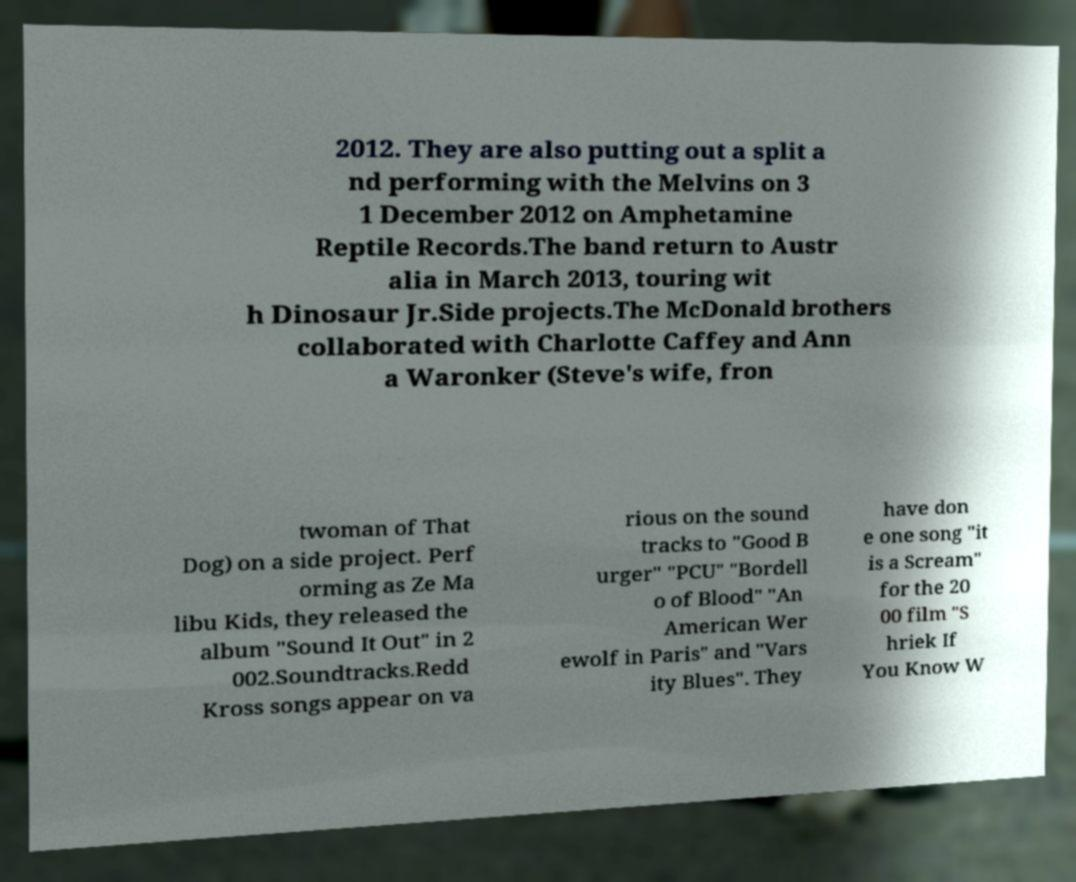Could you assist in decoding the text presented in this image and type it out clearly? 2012. They are also putting out a split a nd performing with the Melvins on 3 1 December 2012 on Amphetamine Reptile Records.The band return to Austr alia in March 2013, touring wit h Dinosaur Jr.Side projects.The McDonald brothers collaborated with Charlotte Caffey and Ann a Waronker (Steve's wife, fron twoman of That Dog) on a side project. Perf orming as Ze Ma libu Kids, they released the album "Sound It Out" in 2 002.Soundtracks.Redd Kross songs appear on va rious on the sound tracks to "Good B urger" "PCU" "Bordell o of Blood" "An American Wer ewolf in Paris" and "Vars ity Blues". They have don e one song "it is a Scream" for the 20 00 film "S hriek If You Know W 